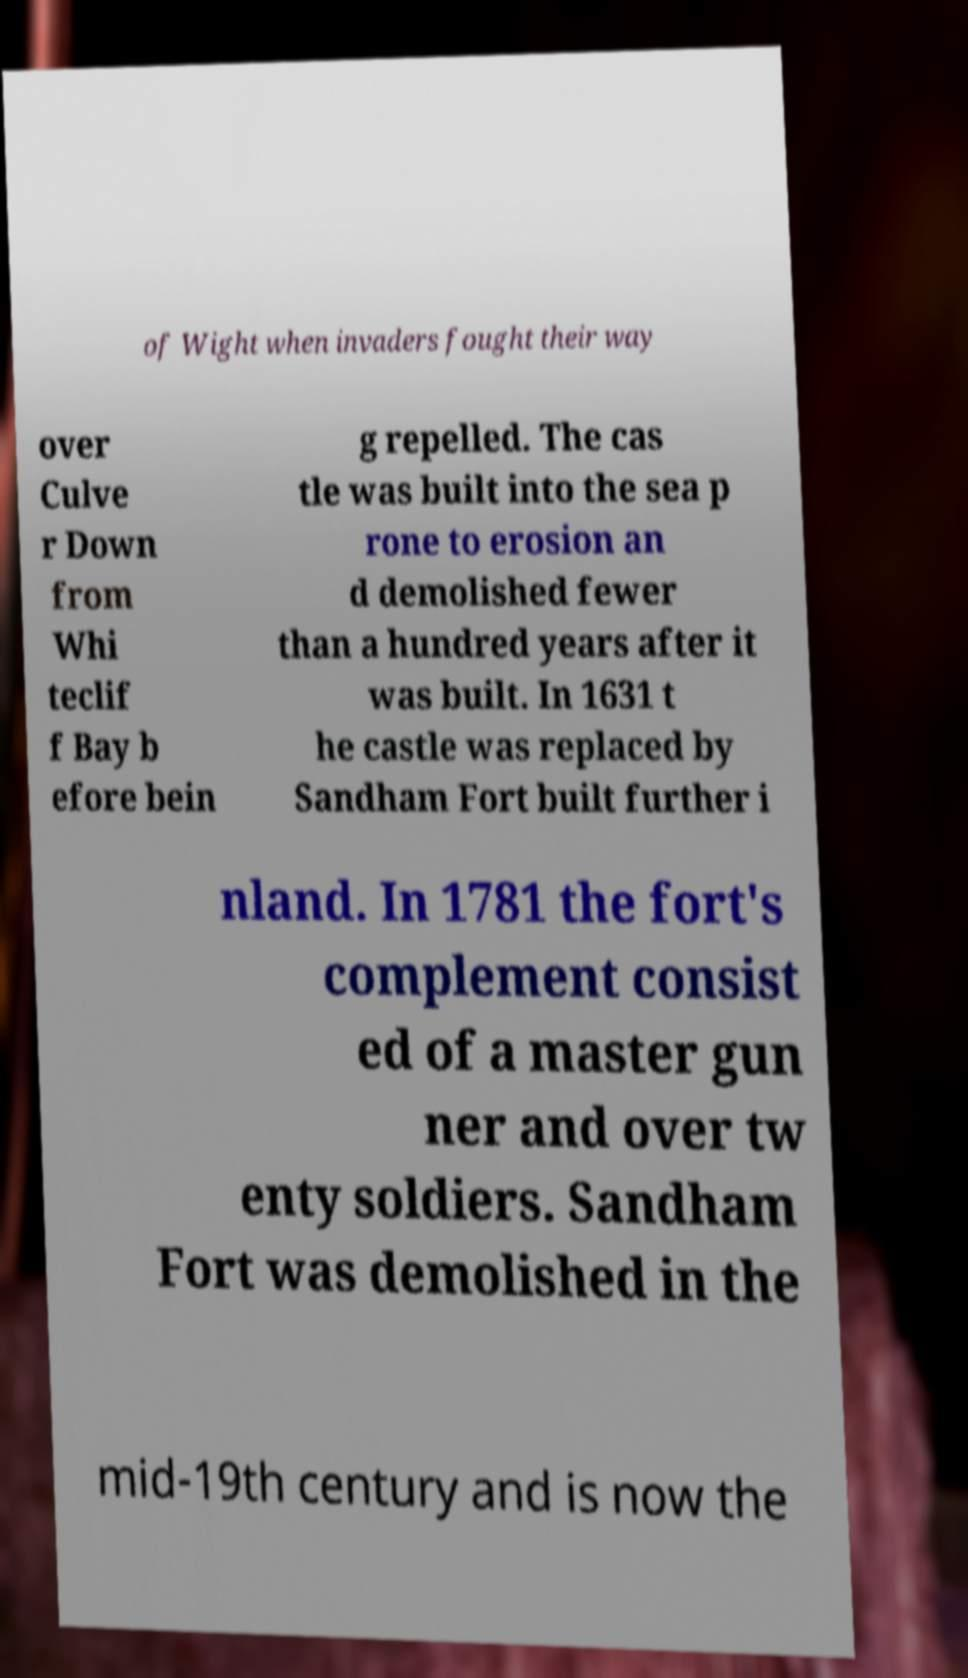I need the written content from this picture converted into text. Can you do that? of Wight when invaders fought their way over Culve r Down from Whi teclif f Bay b efore bein g repelled. The cas tle was built into the sea p rone to erosion an d demolished fewer than a hundred years after it was built. In 1631 t he castle was replaced by Sandham Fort built further i nland. In 1781 the fort's complement consist ed of a master gun ner and over tw enty soldiers. Sandham Fort was demolished in the mid-19th century and is now the 